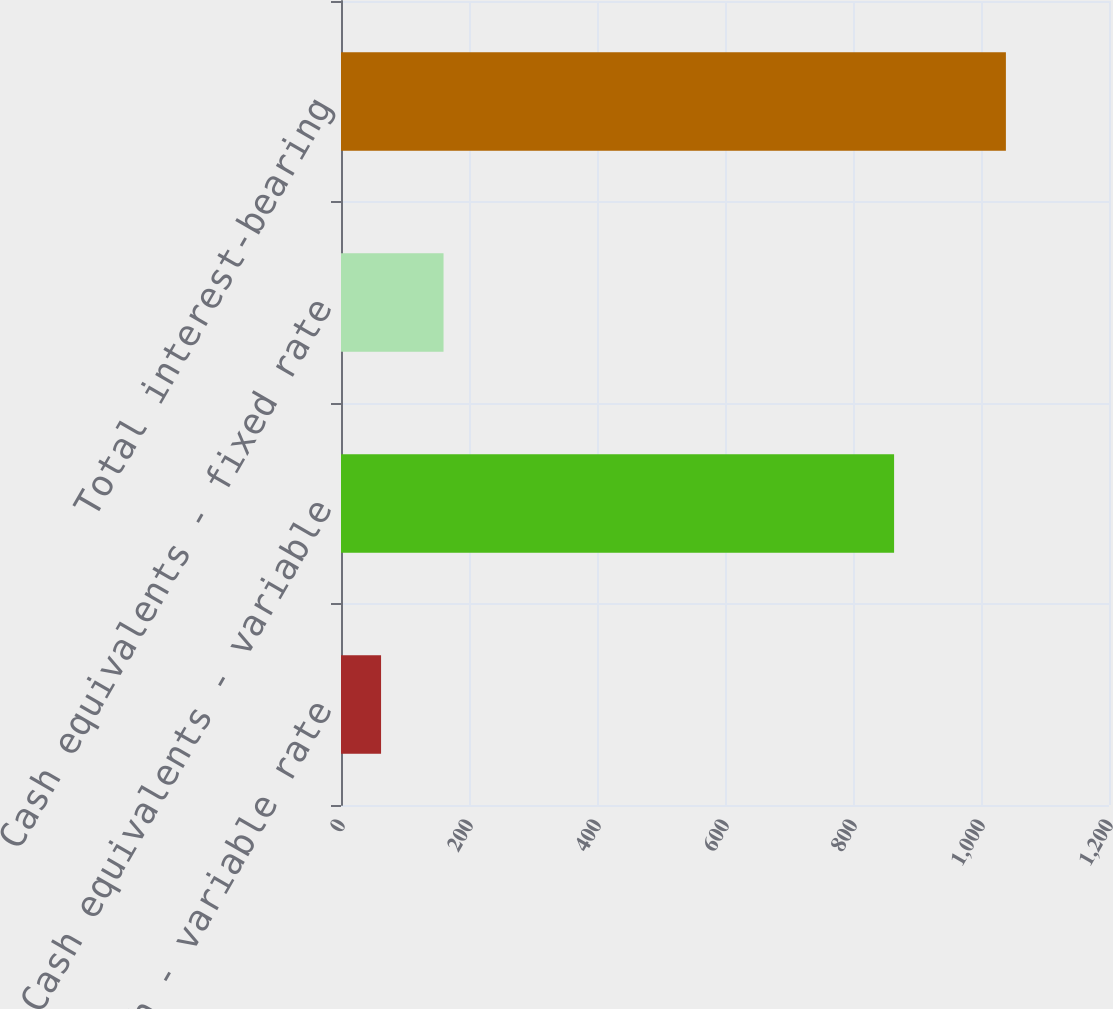<chart> <loc_0><loc_0><loc_500><loc_500><bar_chart><fcel>Cash - variable rate<fcel>Cash equivalents - variable<fcel>Cash equivalents - fixed rate<fcel>Total interest-bearing<nl><fcel>62.6<fcel>864.2<fcel>160.23<fcel>1038.9<nl></chart> 